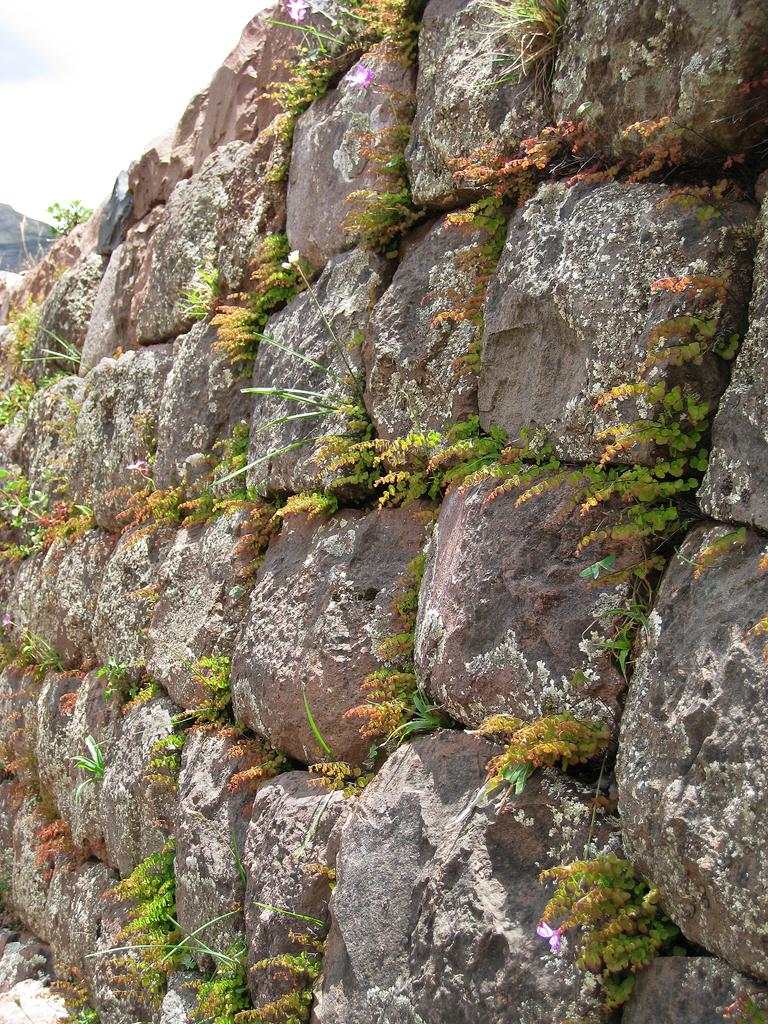What type of structure is visible in the image? There is a stone wall in the image. What else can be seen in the image besides the stone wall? There are plants in the image. Where is the sky visible in the image? The sky is visible in the left side corner of the image. What type of bell can be heard ringing in the image? There is no bell present in the image, and therefore no sound can be heard. 